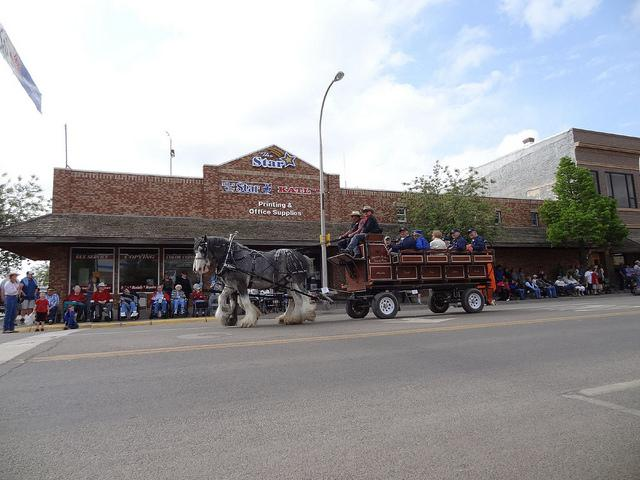What two factors are allowing the people to move? horse buggy 